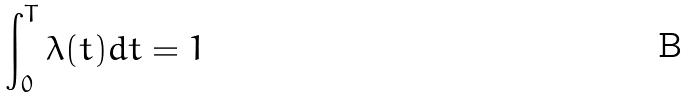Convert formula to latex. <formula><loc_0><loc_0><loc_500><loc_500>\int _ { 0 } ^ { T } \lambda ( t ) d t = 1</formula> 